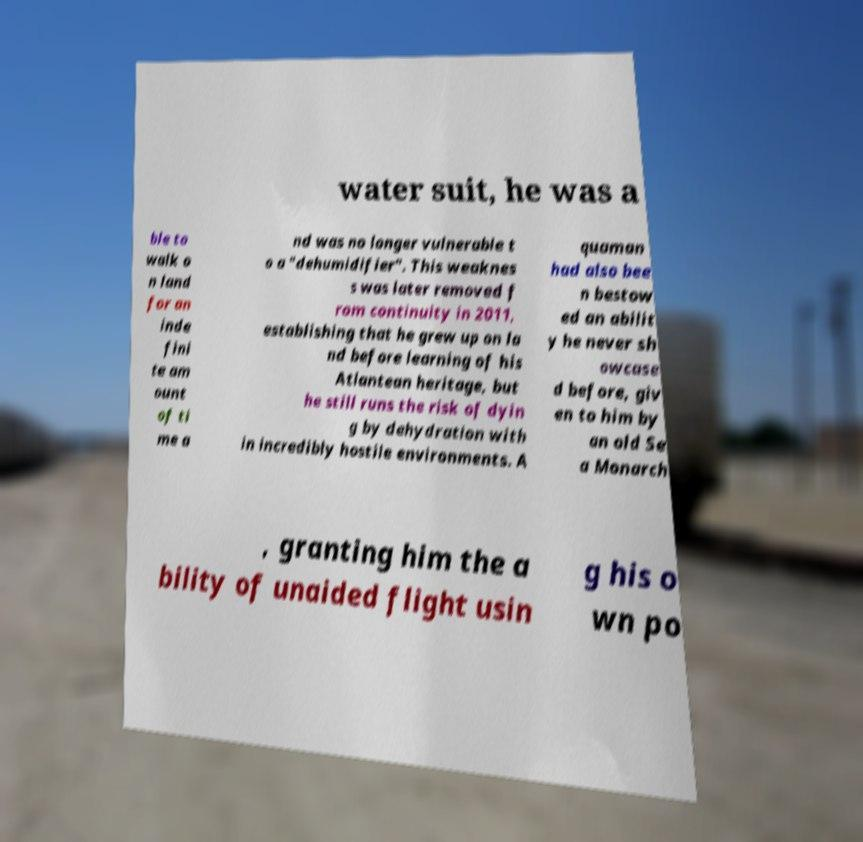Please read and relay the text visible in this image. What does it say? water suit, he was a ble to walk o n land for an inde fini te am ount of ti me a nd was no longer vulnerable t o a "dehumidifier". This weaknes s was later removed f rom continuity in 2011, establishing that he grew up on la nd before learning of his Atlantean heritage, but he still runs the risk of dyin g by dehydration with in incredibly hostile environments. A quaman had also bee n bestow ed an abilit y he never sh owcase d before, giv en to him by an old Se a Monarch , granting him the a bility of unaided flight usin g his o wn po 